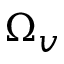<formula> <loc_0><loc_0><loc_500><loc_500>\Omega _ { v }</formula> 